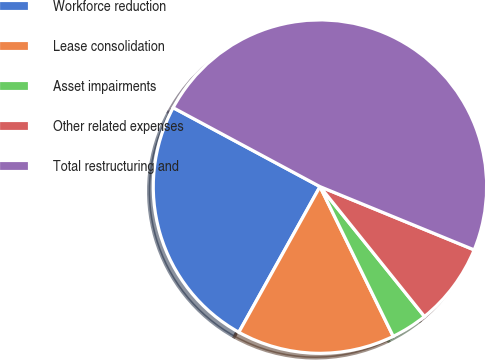Convert chart to OTSL. <chart><loc_0><loc_0><loc_500><loc_500><pie_chart><fcel>Workforce reduction<fcel>Lease consolidation<fcel>Asset impairments<fcel>Other related expenses<fcel>Total restructuring and<nl><fcel>24.76%<fcel>15.33%<fcel>3.54%<fcel>8.02%<fcel>48.35%<nl></chart> 